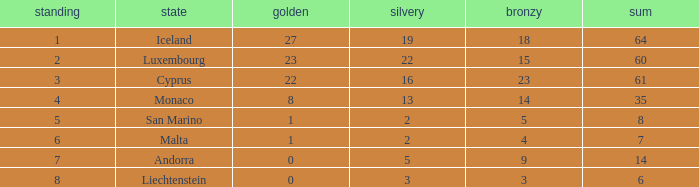How many bronzes for Iceland with over 2 silvers? 18.0. 